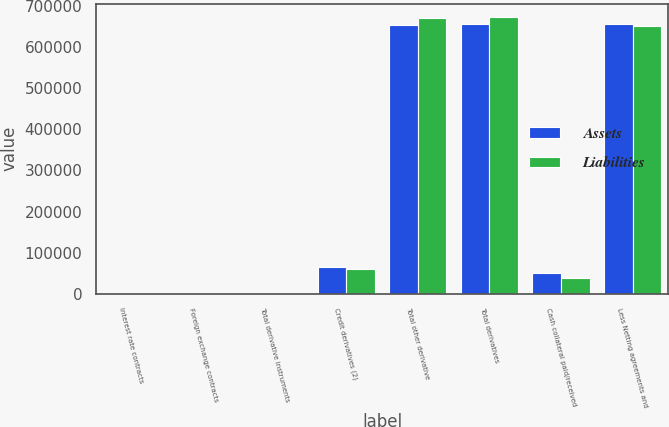<chart> <loc_0><loc_0><loc_500><loc_500><stacked_bar_chart><ecel><fcel>Interest rate contracts<fcel>Foreign exchange contracts<fcel>Total derivative instruments<fcel>Credit derivatives (2)<fcel>Total other derivative<fcel>Total derivatives<fcel>Cash collateral paid/received<fcel>Less Netting agreements and<nl><fcel>Assets<fcel>867<fcel>357<fcel>1224<fcel>65041<fcel>653744<fcel>654968<fcel>50302<fcel>655057<nl><fcel>Liabilities<fcel>72<fcel>762<fcel>834<fcel>59461<fcel>670592<fcel>671426<fcel>38319<fcel>650015<nl></chart> 